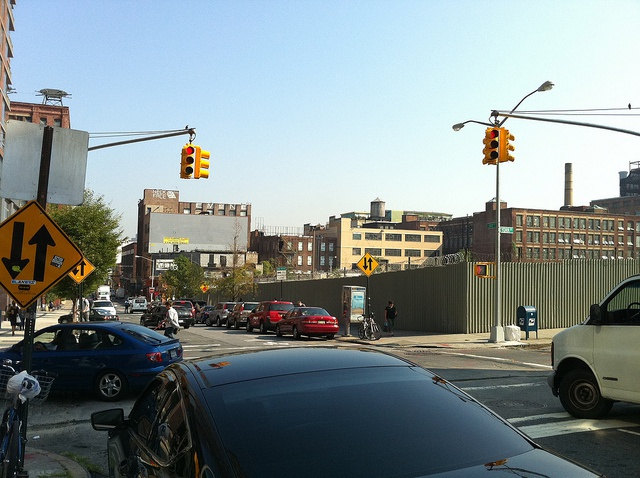Describe the objects in this image and their specific colors. I can see car in gray, black, blue, and darkblue tones, car in gray and black tones, car in gray, black, and navy tones, bicycle in gray, black, darkgray, and darkblue tones, and car in gray, black, maroon, and brown tones in this image. 